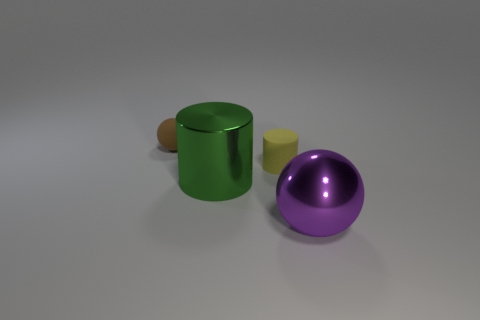Add 2 green objects. How many objects exist? 6 Subtract all green cylinders. How many cylinders are left? 1 Subtract 0 cyan cylinders. How many objects are left? 4 Subtract 2 cylinders. How many cylinders are left? 0 Subtract all green cylinders. Subtract all red blocks. How many cylinders are left? 1 Subtract all blue shiny cubes. Subtract all tiny yellow objects. How many objects are left? 3 Add 2 small things. How many small things are left? 4 Add 3 large shiny balls. How many large shiny balls exist? 4 